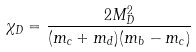Convert formula to latex. <formula><loc_0><loc_0><loc_500><loc_500>\chi _ { D } = \frac { 2 M _ { D } ^ { 2 } } { ( m _ { c } + m _ { d } ) ( m _ { b } - m _ { c } ) }</formula> 